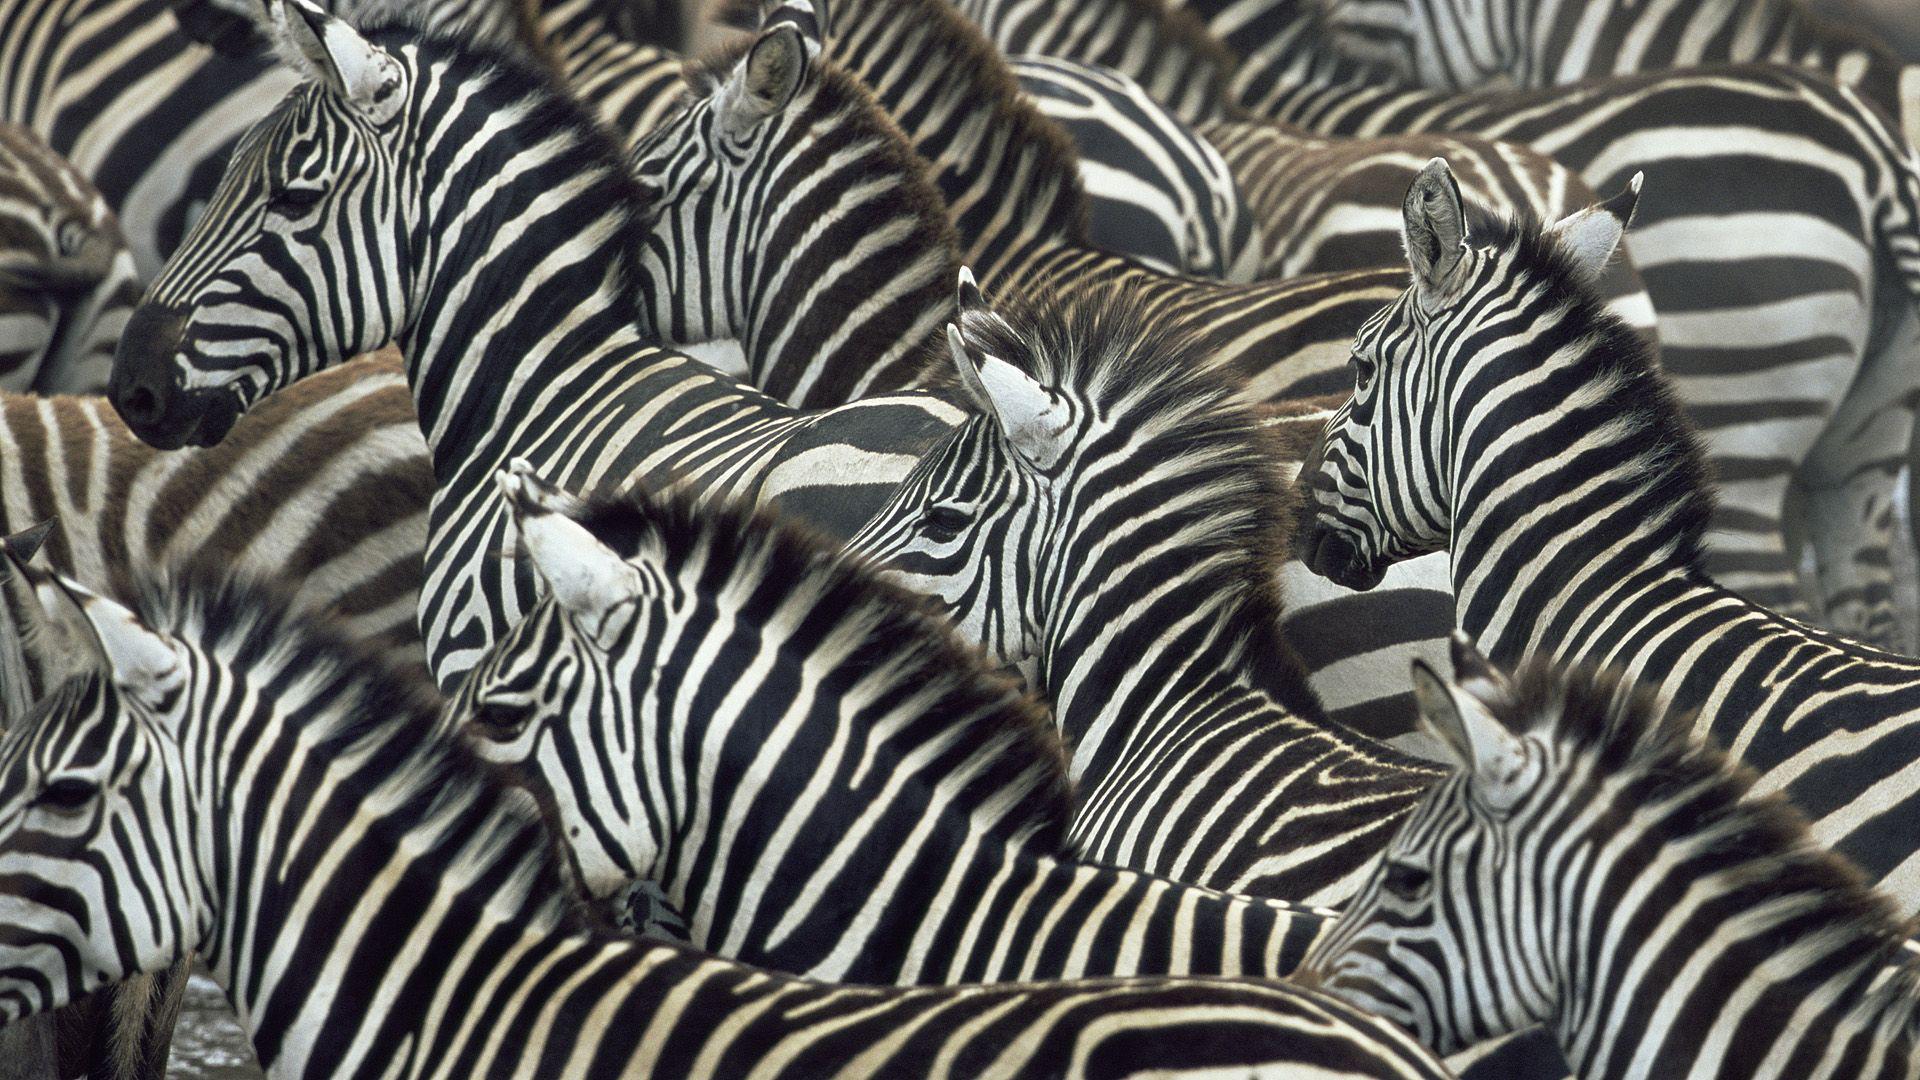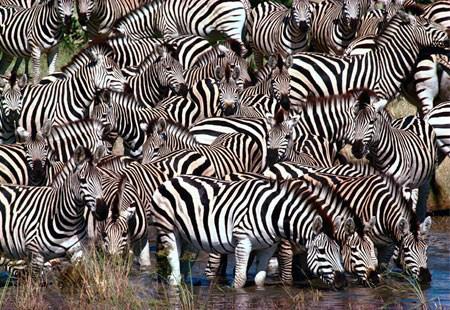The first image is the image on the left, the second image is the image on the right. Assess this claim about the two images: "At least one image shows a row of zebras in similar poses in terms of the way their bodies are turned and their eyes are gazing.". Correct or not? Answer yes or no. No. The first image is the image on the left, the second image is the image on the right. For the images displayed, is the sentence "Some zebras are eating grass." factually correct? Answer yes or no. No. 